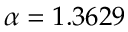Convert formula to latex. <formula><loc_0><loc_0><loc_500><loc_500>\alpha = 1 . 3 6 2 9</formula> 